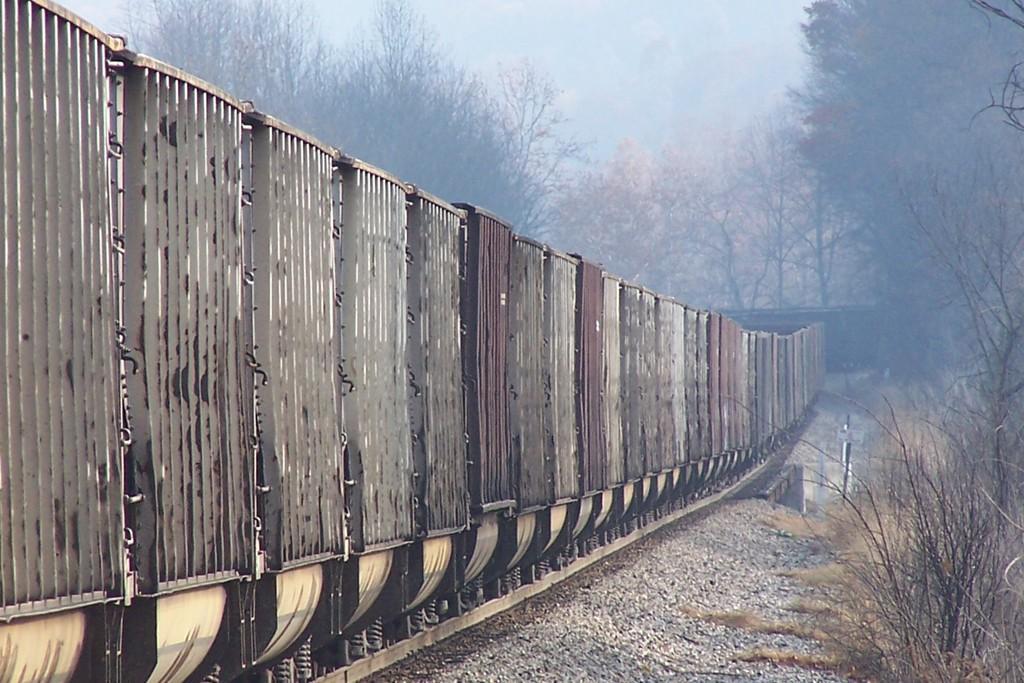Could you give a brief overview of what you see in this image? As we can see in the image there is a train, railway track, plants, trees and sky. 